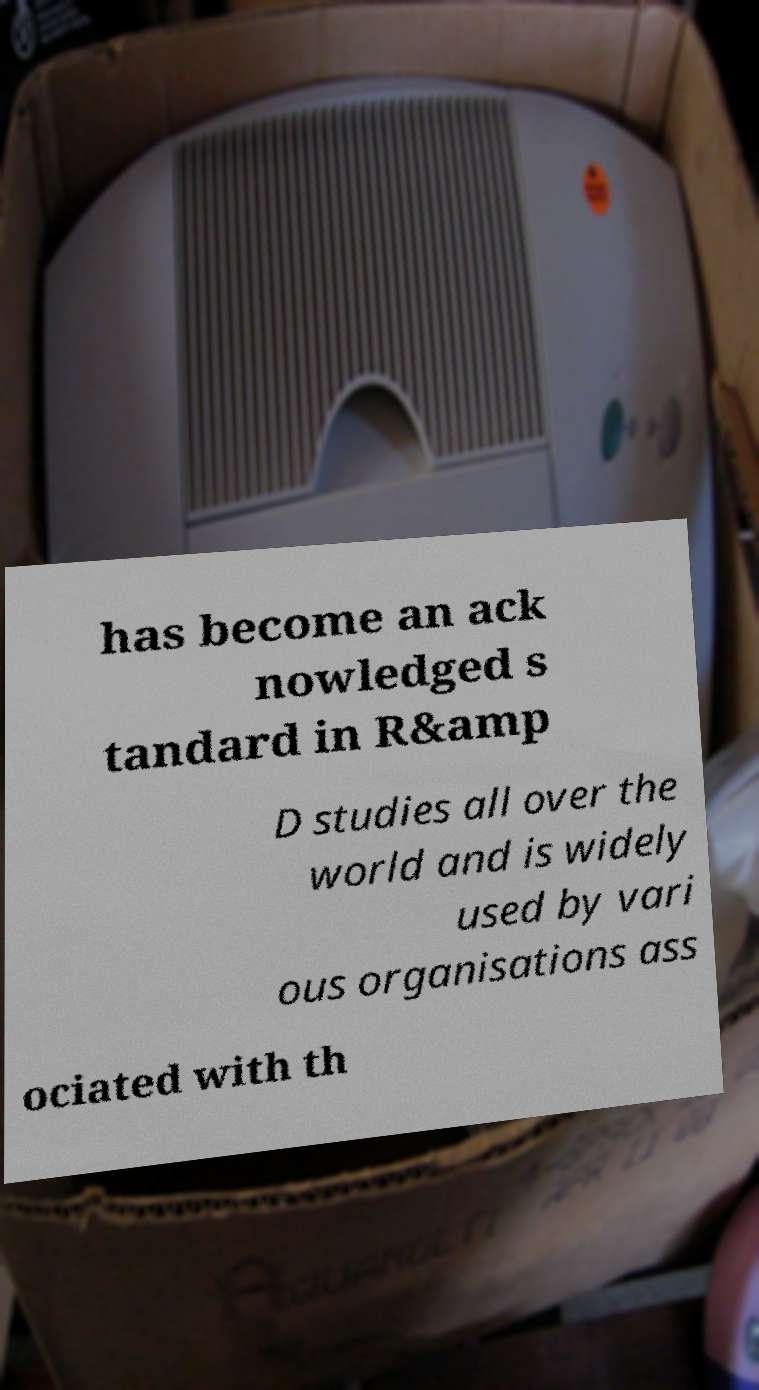For documentation purposes, I need the text within this image transcribed. Could you provide that? has become an ack nowledged s tandard in R&amp D studies all over the world and is widely used by vari ous organisations ass ociated with th 